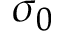Convert formula to latex. <formula><loc_0><loc_0><loc_500><loc_500>\sigma _ { 0 }</formula> 